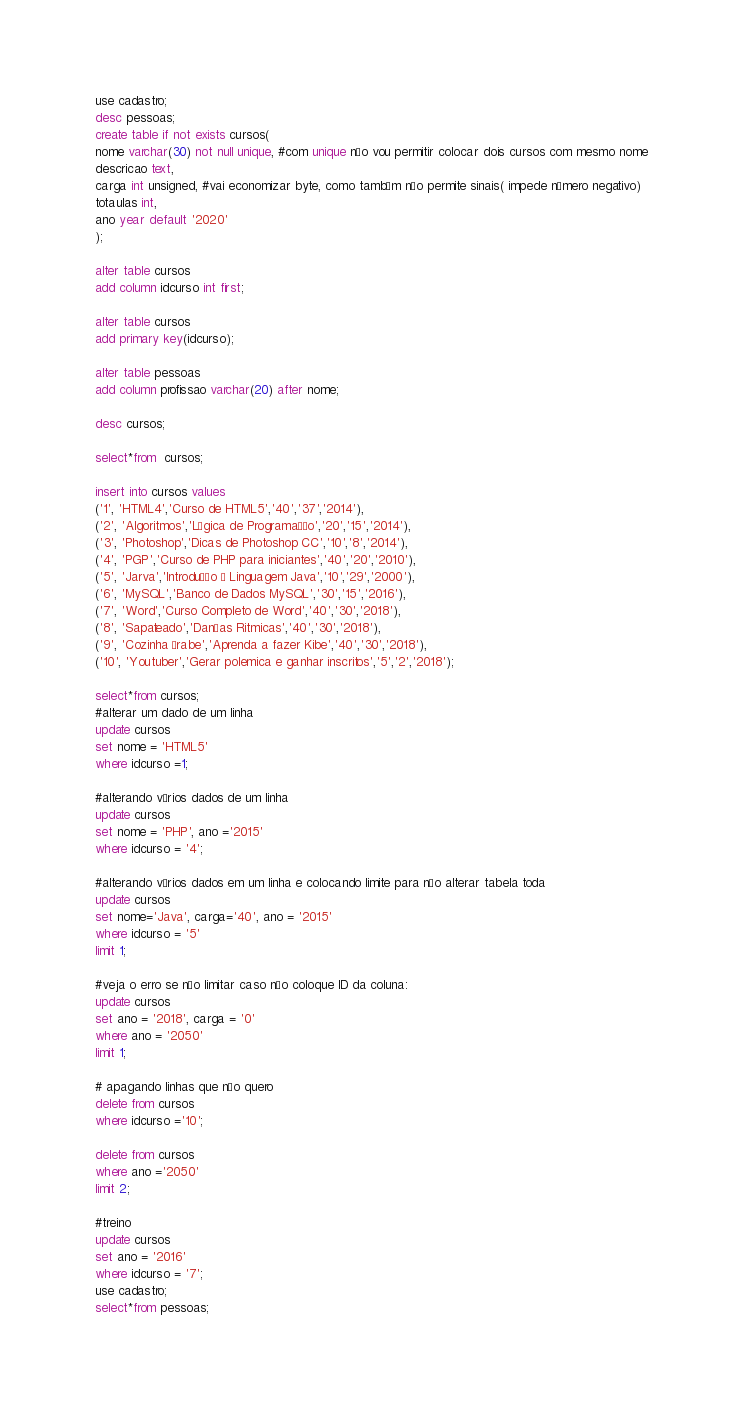<code> <loc_0><loc_0><loc_500><loc_500><_SQL_>use cadastro;
desc pessoas;
create table if not exists cursos(
nome varchar(30) not null unique, #com unique não vou permitir colocar dois cursos com mesmo nome
descricao text,
carga int unsigned, #vai economizar byte, como também não permite sinais( impede número negativo)
totaulas int,
ano year default '2020'
);

alter table cursos
add column idcurso int first;

alter table cursos
add primary key(idcurso);

alter table pessoas
add column profissao varchar(20) after nome;

desc cursos;

select*from  cursos;

insert into cursos values
('1', 'HTML4','Curso de HTML5','40','37','2014'),
('2', 'Algoritmos','Lógica de Programação','20','15','2014'),
('3', 'Photoshop','Dicas de Photoshop CC','10','8','2014'),
('4', 'PGP','Curso de PHP para iniciantes','40','20','2010'),
('5', 'Jarva','Introdução à Linguagem Java','10','29','2000'),
('6', 'MySQL','Banco de Dados MySQL','30','15','2016'),
('7', 'Word','Curso Completo de Word','40','30','2018'),
('8', 'Sapateado','Danças Ritmicas','40','30','2018'),
('9', 'Cozinha Árabe','Aprenda a fazer Kibe','40','30','2018'),
('10', 'Youtuber','Gerar polemica e ganhar inscritos','5','2','2018');

select*from cursos;
#alterar um dado de um linha
update cursos
set nome = 'HTML5'
where idcurso =1;

#alterando vários dados de um linha
update cursos
set nome = 'PHP', ano ='2015'
where idcurso = '4';

#alterando vários dados em um linha e colocando limite para não alterar tabela toda
update cursos
set nome='Java', carga='40', ano = '2015'
where idcurso = '5'
limit 1;

#veja o erro se não limitar caso não coloque ID da coluna:
update cursos
set ano = '2018', carga = '0'
where ano = '2050'
limit 1;

# apagando linhas que não quero
delete from cursos
where idcurso ='10';

delete from cursos
where ano ='2050'
limit 2;

#treino
update cursos
set ano = '2016'
where idcurso = '7';
use cadastro;
select*from pessoas;

</code> 